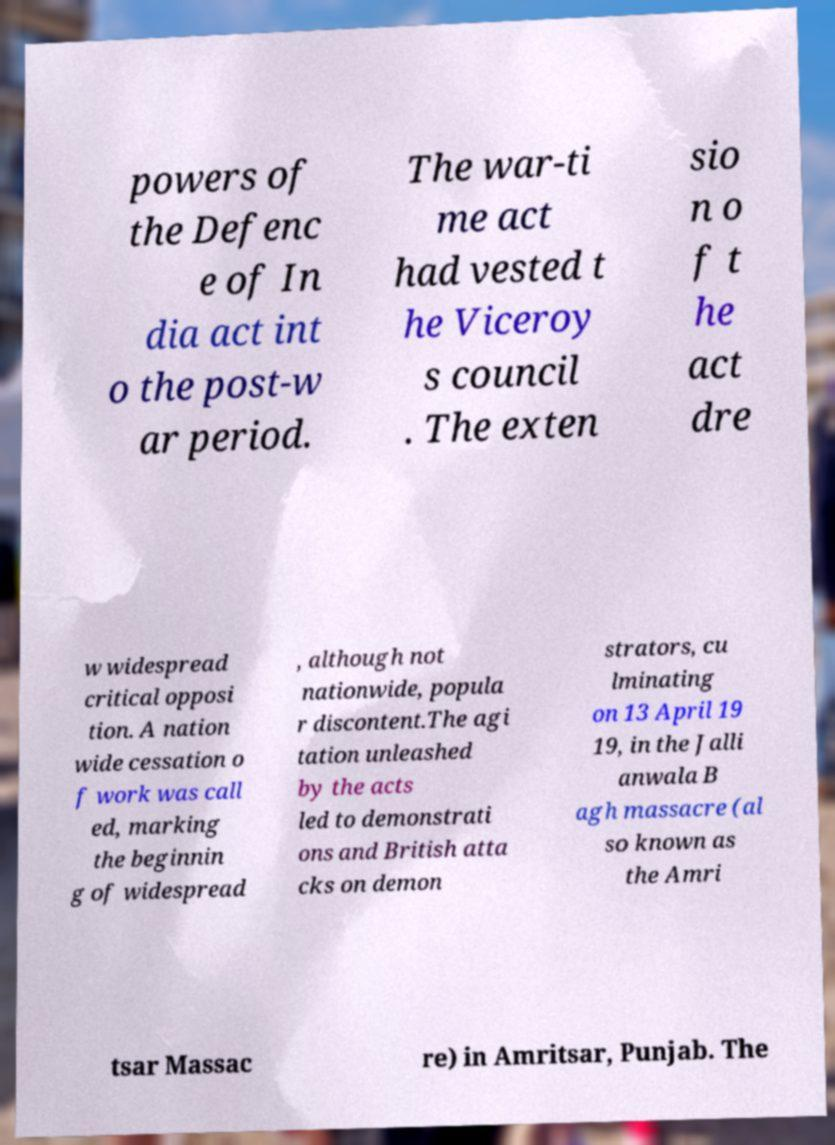What messages or text are displayed in this image? I need them in a readable, typed format. powers of the Defenc e of In dia act int o the post-w ar period. The war-ti me act had vested t he Viceroy s council . The exten sio n o f t he act dre w widespread critical opposi tion. A nation wide cessation o f work was call ed, marking the beginnin g of widespread , although not nationwide, popula r discontent.The agi tation unleashed by the acts led to demonstrati ons and British atta cks on demon strators, cu lminating on 13 April 19 19, in the Jalli anwala B agh massacre (al so known as the Amri tsar Massac re) in Amritsar, Punjab. The 